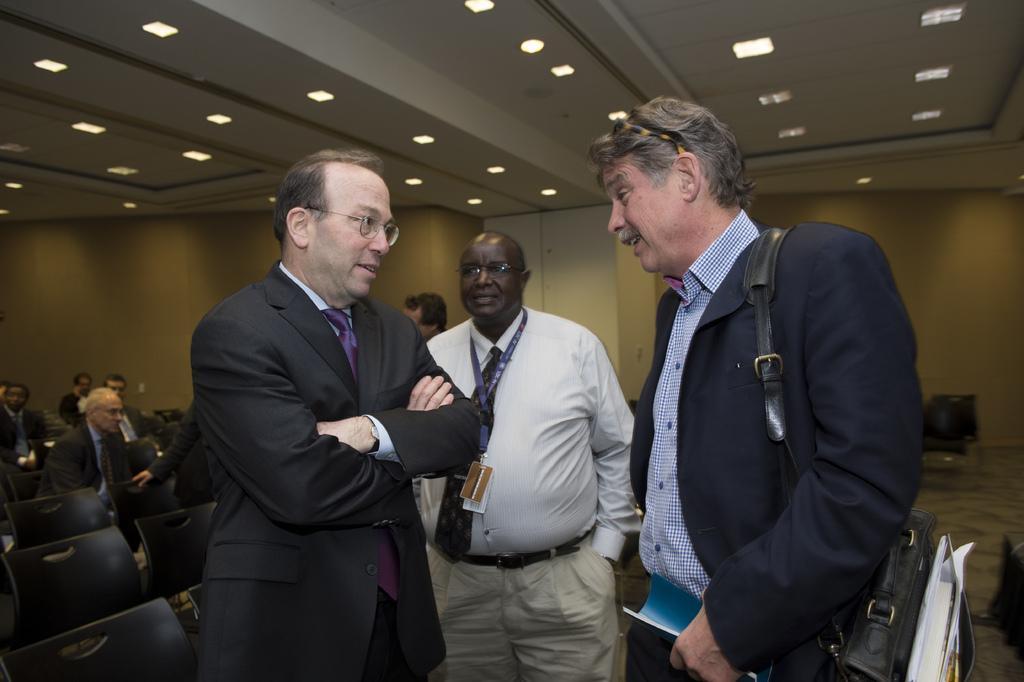Describe this image in one or two sentences. In this picture, we can see a few people, sitting, and a few are standing, holding some objects, and we can see a few are talking each other, and we can see chairs, ground, wall, and the roof with lights. 